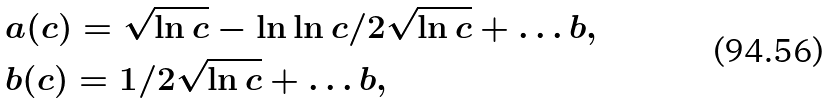Convert formula to latex. <formula><loc_0><loc_0><loc_500><loc_500>& a ( c ) = \sqrt { \ln c } - \ln \ln c / 2 \sqrt { \ln c } + \dots b , \\ & b ( c ) = 1 / 2 \sqrt { \ln c } + \dots b ,</formula> 